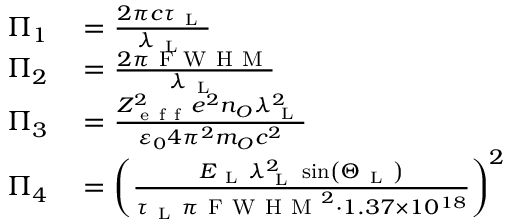<formula> <loc_0><loc_0><loc_500><loc_500>\begin{array} { r l } { \Pi _ { 1 } } & = \frac { 2 \pi c \tau _ { L } } { \lambda _ { L } } } \\ { \Pi _ { 2 } } & = \frac { 2 \pi F W H M } { \lambda _ { L } } } \\ { \Pi _ { 3 } } & = \frac { Z _ { e f f } ^ { 2 } e ^ { 2 } n _ { O } \lambda _ { L } ^ { 2 } } { \varepsilon _ { 0 } 4 \pi ^ { 2 } m _ { O } c ^ { 2 } } } \\ { \Pi _ { 4 } } & = \left ( \frac { E _ { L } \lambda _ { L } ^ { 2 } \sin \left ( \Theta _ { L } \right ) } { \tau _ { L } \pi F W H M ^ { 2 } \cdot 1 . 3 7 \times 1 0 ^ { 1 8 } } \right ) ^ { 2 } } \end{array}</formula> 